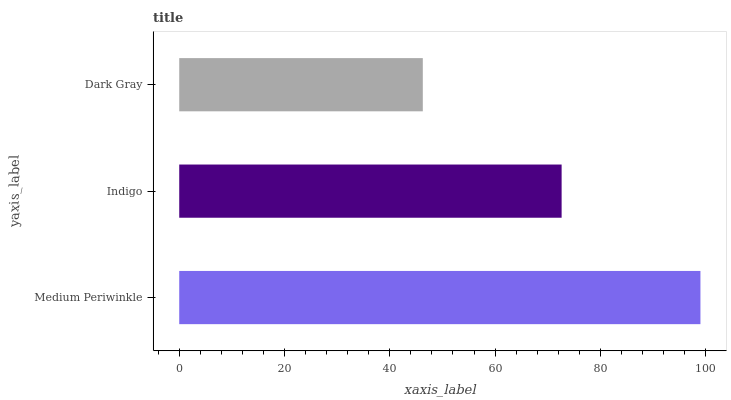Is Dark Gray the minimum?
Answer yes or no. Yes. Is Medium Periwinkle the maximum?
Answer yes or no. Yes. Is Indigo the minimum?
Answer yes or no. No. Is Indigo the maximum?
Answer yes or no. No. Is Medium Periwinkle greater than Indigo?
Answer yes or no. Yes. Is Indigo less than Medium Periwinkle?
Answer yes or no. Yes. Is Indigo greater than Medium Periwinkle?
Answer yes or no. No. Is Medium Periwinkle less than Indigo?
Answer yes or no. No. Is Indigo the high median?
Answer yes or no. Yes. Is Indigo the low median?
Answer yes or no. Yes. Is Dark Gray the high median?
Answer yes or no. No. Is Medium Periwinkle the low median?
Answer yes or no. No. 